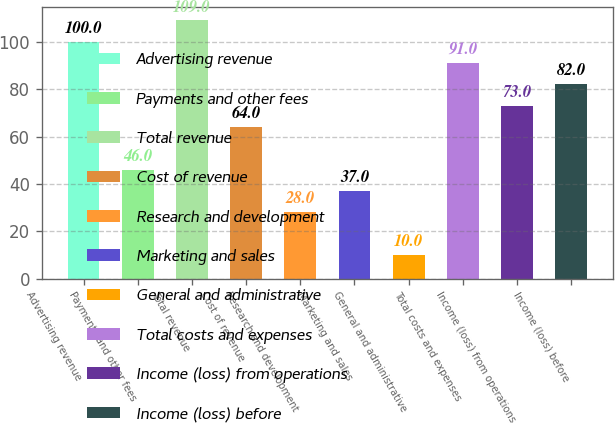Convert chart. <chart><loc_0><loc_0><loc_500><loc_500><bar_chart><fcel>Advertising revenue<fcel>Payments and other fees<fcel>Total revenue<fcel>Cost of revenue<fcel>Research and development<fcel>Marketing and sales<fcel>General and administrative<fcel>Total costs and expenses<fcel>Income (loss) from operations<fcel>Income (loss) before<nl><fcel>100<fcel>46<fcel>109<fcel>64<fcel>28<fcel>37<fcel>10<fcel>91<fcel>73<fcel>82<nl></chart> 